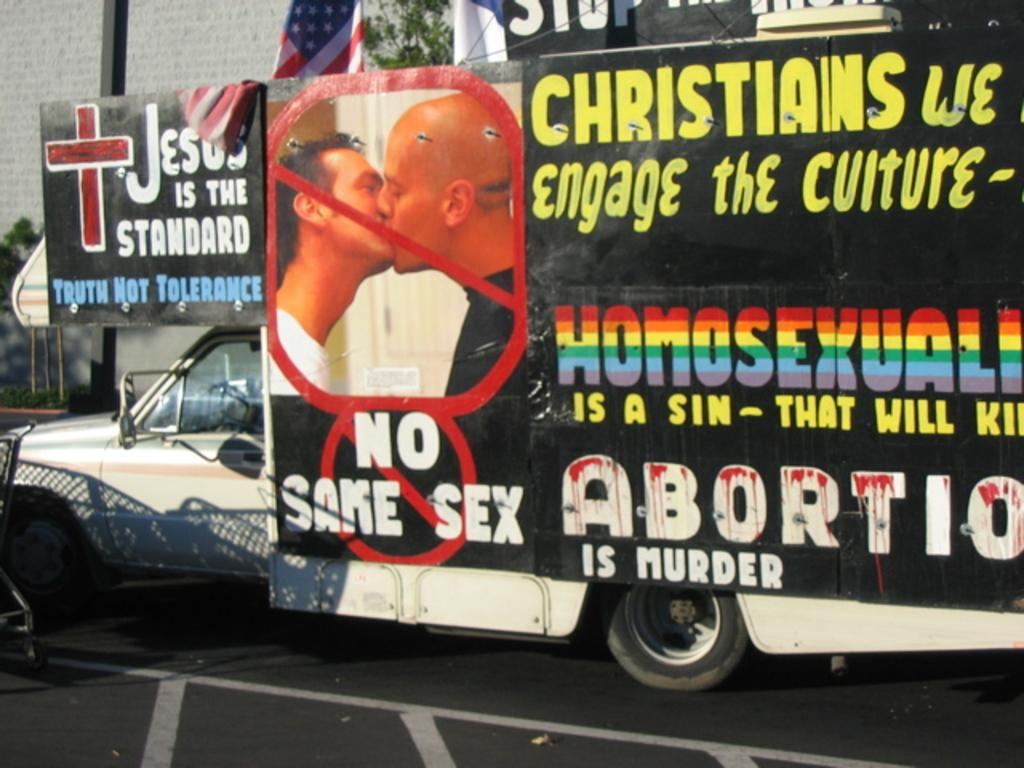What is attached to the vehicle in the image? There is a banner attached to a vehicle in the image. What can be seen in the background of the image? There are trees, a flag, and a building in the background of the image. How many boys are pushing the vehicle in the image? There is no indication of boys or any pushing motion in the image. What type of motion is the vehicle exhibiting in the image? The image does not show any motion of the vehicle; it is stationary with the banner attached. 